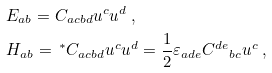<formula> <loc_0><loc_0><loc_500><loc_500>& E _ { a b } = C _ { a c b d } u ^ { c } u ^ { d } \ , \\ & H _ { a b } = \, ^ { \ast } C _ { a c b d } u ^ { c } u ^ { d } = { \frac { 1 } { 2 } } \varepsilon _ { a d e } { C ^ { d e } } _ { b c } u ^ { c } \ ,</formula> 